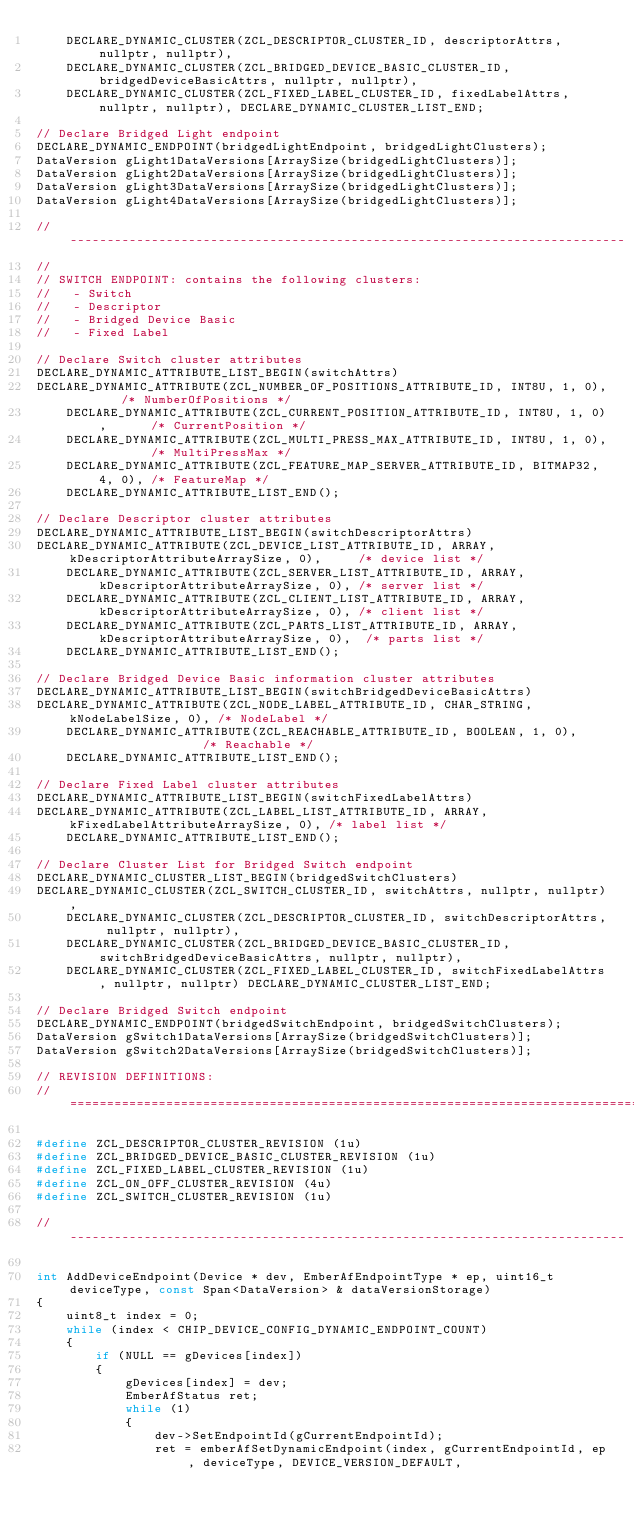Convert code to text. <code><loc_0><loc_0><loc_500><loc_500><_C++_>    DECLARE_DYNAMIC_CLUSTER(ZCL_DESCRIPTOR_CLUSTER_ID, descriptorAttrs, nullptr, nullptr),
    DECLARE_DYNAMIC_CLUSTER(ZCL_BRIDGED_DEVICE_BASIC_CLUSTER_ID, bridgedDeviceBasicAttrs, nullptr, nullptr),
    DECLARE_DYNAMIC_CLUSTER(ZCL_FIXED_LABEL_CLUSTER_ID, fixedLabelAttrs, nullptr, nullptr), DECLARE_DYNAMIC_CLUSTER_LIST_END;

// Declare Bridged Light endpoint
DECLARE_DYNAMIC_ENDPOINT(bridgedLightEndpoint, bridgedLightClusters);
DataVersion gLight1DataVersions[ArraySize(bridgedLightClusters)];
DataVersion gLight2DataVersions[ArraySize(bridgedLightClusters)];
DataVersion gLight3DataVersions[ArraySize(bridgedLightClusters)];
DataVersion gLight4DataVersions[ArraySize(bridgedLightClusters)];

// ---------------------------------------------------------------------------
//
// SWITCH ENDPOINT: contains the following clusters:
//   - Switch
//   - Descriptor
//   - Bridged Device Basic
//   - Fixed Label

// Declare Switch cluster attributes
DECLARE_DYNAMIC_ATTRIBUTE_LIST_BEGIN(switchAttrs)
DECLARE_DYNAMIC_ATTRIBUTE(ZCL_NUMBER_OF_POSITIONS_ATTRIBUTE_ID, INT8U, 1, 0),       /* NumberOfPositions */
    DECLARE_DYNAMIC_ATTRIBUTE(ZCL_CURRENT_POSITION_ATTRIBUTE_ID, INT8U, 1, 0),      /* CurrentPosition */
    DECLARE_DYNAMIC_ATTRIBUTE(ZCL_MULTI_PRESS_MAX_ATTRIBUTE_ID, INT8U, 1, 0),       /* MultiPressMax */
    DECLARE_DYNAMIC_ATTRIBUTE(ZCL_FEATURE_MAP_SERVER_ATTRIBUTE_ID, BITMAP32, 4, 0), /* FeatureMap */
    DECLARE_DYNAMIC_ATTRIBUTE_LIST_END();

// Declare Descriptor cluster attributes
DECLARE_DYNAMIC_ATTRIBUTE_LIST_BEGIN(switchDescriptorAttrs)
DECLARE_DYNAMIC_ATTRIBUTE(ZCL_DEVICE_LIST_ATTRIBUTE_ID, ARRAY, kDescriptorAttributeArraySize, 0),     /* device list */
    DECLARE_DYNAMIC_ATTRIBUTE(ZCL_SERVER_LIST_ATTRIBUTE_ID, ARRAY, kDescriptorAttributeArraySize, 0), /* server list */
    DECLARE_DYNAMIC_ATTRIBUTE(ZCL_CLIENT_LIST_ATTRIBUTE_ID, ARRAY, kDescriptorAttributeArraySize, 0), /* client list */
    DECLARE_DYNAMIC_ATTRIBUTE(ZCL_PARTS_LIST_ATTRIBUTE_ID, ARRAY, kDescriptorAttributeArraySize, 0),  /* parts list */
    DECLARE_DYNAMIC_ATTRIBUTE_LIST_END();

// Declare Bridged Device Basic information cluster attributes
DECLARE_DYNAMIC_ATTRIBUTE_LIST_BEGIN(switchBridgedDeviceBasicAttrs)
DECLARE_DYNAMIC_ATTRIBUTE(ZCL_NODE_LABEL_ATTRIBUTE_ID, CHAR_STRING, kNodeLabelSize, 0), /* NodeLabel */
    DECLARE_DYNAMIC_ATTRIBUTE(ZCL_REACHABLE_ATTRIBUTE_ID, BOOLEAN, 1, 0),               /* Reachable */
    DECLARE_DYNAMIC_ATTRIBUTE_LIST_END();

// Declare Fixed Label cluster attributes
DECLARE_DYNAMIC_ATTRIBUTE_LIST_BEGIN(switchFixedLabelAttrs)
DECLARE_DYNAMIC_ATTRIBUTE(ZCL_LABEL_LIST_ATTRIBUTE_ID, ARRAY, kFixedLabelAttributeArraySize, 0), /* label list */
    DECLARE_DYNAMIC_ATTRIBUTE_LIST_END();

// Declare Cluster List for Bridged Switch endpoint
DECLARE_DYNAMIC_CLUSTER_LIST_BEGIN(bridgedSwitchClusters)
DECLARE_DYNAMIC_CLUSTER(ZCL_SWITCH_CLUSTER_ID, switchAttrs, nullptr, nullptr),
    DECLARE_DYNAMIC_CLUSTER(ZCL_DESCRIPTOR_CLUSTER_ID, switchDescriptorAttrs, nullptr, nullptr),
    DECLARE_DYNAMIC_CLUSTER(ZCL_BRIDGED_DEVICE_BASIC_CLUSTER_ID, switchBridgedDeviceBasicAttrs, nullptr, nullptr),
    DECLARE_DYNAMIC_CLUSTER(ZCL_FIXED_LABEL_CLUSTER_ID, switchFixedLabelAttrs, nullptr, nullptr) DECLARE_DYNAMIC_CLUSTER_LIST_END;

// Declare Bridged Switch endpoint
DECLARE_DYNAMIC_ENDPOINT(bridgedSwitchEndpoint, bridgedSwitchClusters);
DataVersion gSwitch1DataVersions[ArraySize(bridgedSwitchClusters)];
DataVersion gSwitch2DataVersions[ArraySize(bridgedSwitchClusters)];

// REVISION DEFINITIONS:
// =================================================================================

#define ZCL_DESCRIPTOR_CLUSTER_REVISION (1u)
#define ZCL_BRIDGED_DEVICE_BASIC_CLUSTER_REVISION (1u)
#define ZCL_FIXED_LABEL_CLUSTER_REVISION (1u)
#define ZCL_ON_OFF_CLUSTER_REVISION (4u)
#define ZCL_SWITCH_CLUSTER_REVISION (1u)

// ---------------------------------------------------------------------------

int AddDeviceEndpoint(Device * dev, EmberAfEndpointType * ep, uint16_t deviceType, const Span<DataVersion> & dataVersionStorage)
{
    uint8_t index = 0;
    while (index < CHIP_DEVICE_CONFIG_DYNAMIC_ENDPOINT_COUNT)
    {
        if (NULL == gDevices[index])
        {
            gDevices[index] = dev;
            EmberAfStatus ret;
            while (1)
            {
                dev->SetEndpointId(gCurrentEndpointId);
                ret = emberAfSetDynamicEndpoint(index, gCurrentEndpointId, ep, deviceType, DEVICE_VERSION_DEFAULT,</code> 